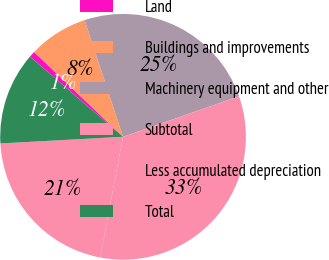Convert chart. <chart><loc_0><loc_0><loc_500><loc_500><pie_chart><fcel>Land<fcel>Buildings and improvements<fcel>Machinery equipment and other<fcel>Subtotal<fcel>Less accumulated depreciation<fcel>Total<nl><fcel>0.8%<fcel>7.82%<fcel>24.71%<fcel>33.33%<fcel>21.16%<fcel>12.18%<nl></chart> 